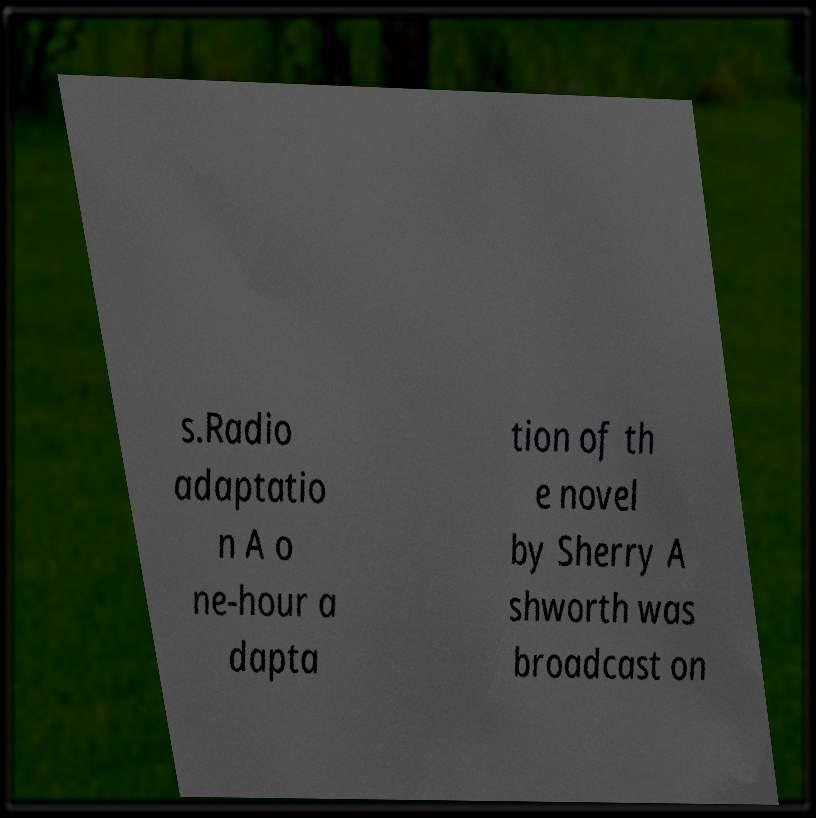I need the written content from this picture converted into text. Can you do that? s.Radio adaptatio n A o ne-hour a dapta tion of th e novel by Sherry A shworth was broadcast on 